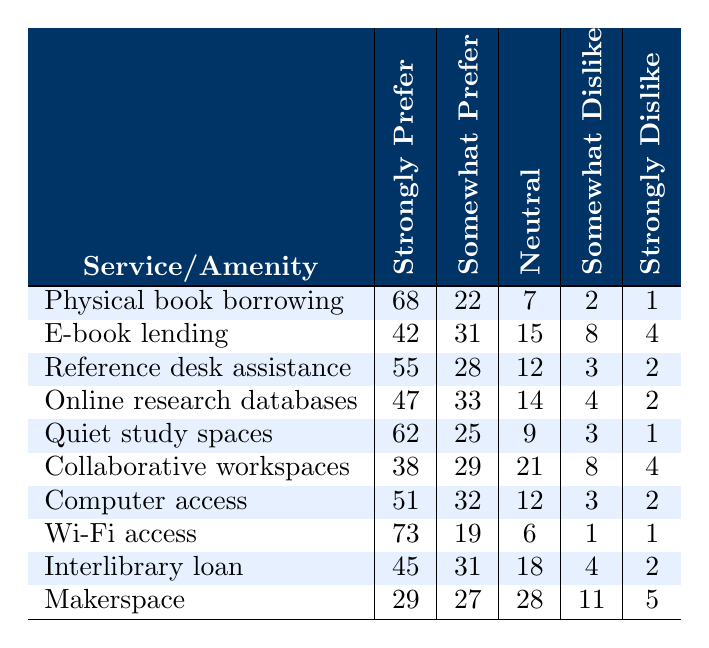What is the service that has the highest "Strongly Prefer" rating? Looking at the "Strongly Prefer" column, "Wi-Fi access" has the highest rating of 73.
Answer: Wi-Fi access How many patrons "Strongly Prefer" e-book lending compared to physical book borrowing? The "Strongly Prefer" rating for e-book lending is 42, while for physical book borrowing it is 68. The difference is 68 - 42 = 26.
Answer: 26 What percentage of patrons "Somewhat Prefer" collaborative workspaces? The "Somewhat Prefer" rating for collaborative workspaces is 29 out of the total responses for that amenity (which is the sum of all preference ratings: 38 + 29 + 21 + 8 + 4 = 100). Therefore, the percentage is (29/100) * 100 = 29%.
Answer: 29% Is the "Strongly Dislike" percentage for quiet study spaces higher than that for computer access? The "Strongly Dislike" rating for quiet study spaces is 1 and for computer access it is 2. Since 1 is less than 2, the statement is false.
Answer: No What is the total number of patrons who prefer physical book borrowing over e-book lending? For physical book borrowing, the total is 68 (Strongly Prefer) + 22 (Somewhat Prefer) = 90. For e-book lending, it's 42 + 31 = 73. The difference is 90 - 73 = 17.
Answer: 17 What is the average "Neutral" rating across all services and amenities? The "Neutral" ratings for all the services are: 7, 15, 12, 14, 9, 21, 12, 6, 18, 28. Summing these gives 7 + 15 + 12 + 14 + 9 + 21 + 12 + 6 + 18 + 28 = 142. There are 10 services so the average is 142/10 = 14.2.
Answer: 14.2 Which service received the most "Somewhat Dislike" ratings? Looking at the "Somewhat Dislike" column, the highest rating is for "Makerspace" with 11, while the others have lower ratings.
Answer: Makerspace Determine the number of patrons who are neutral about online research databases. The "Neutral" rating for online research databases is explicitly listed as 14.
Answer: 14 Is it true that fewer patrons "Strongly Prefer" computer access than "Strongly Prefer" reference desk assistance? The "Strongly Prefer" rating for computer access is 51 and for reference desk assistance it is 55. Since 51 is less than 55, this statement is true.
Answer: Yes What is the total number of patrons who prefer e-book lending? The total number of patrons who prefer e-book lending is 42 (Strongly Prefer) + 31 (Somewhat Prefer) = 73.
Answer: 73 